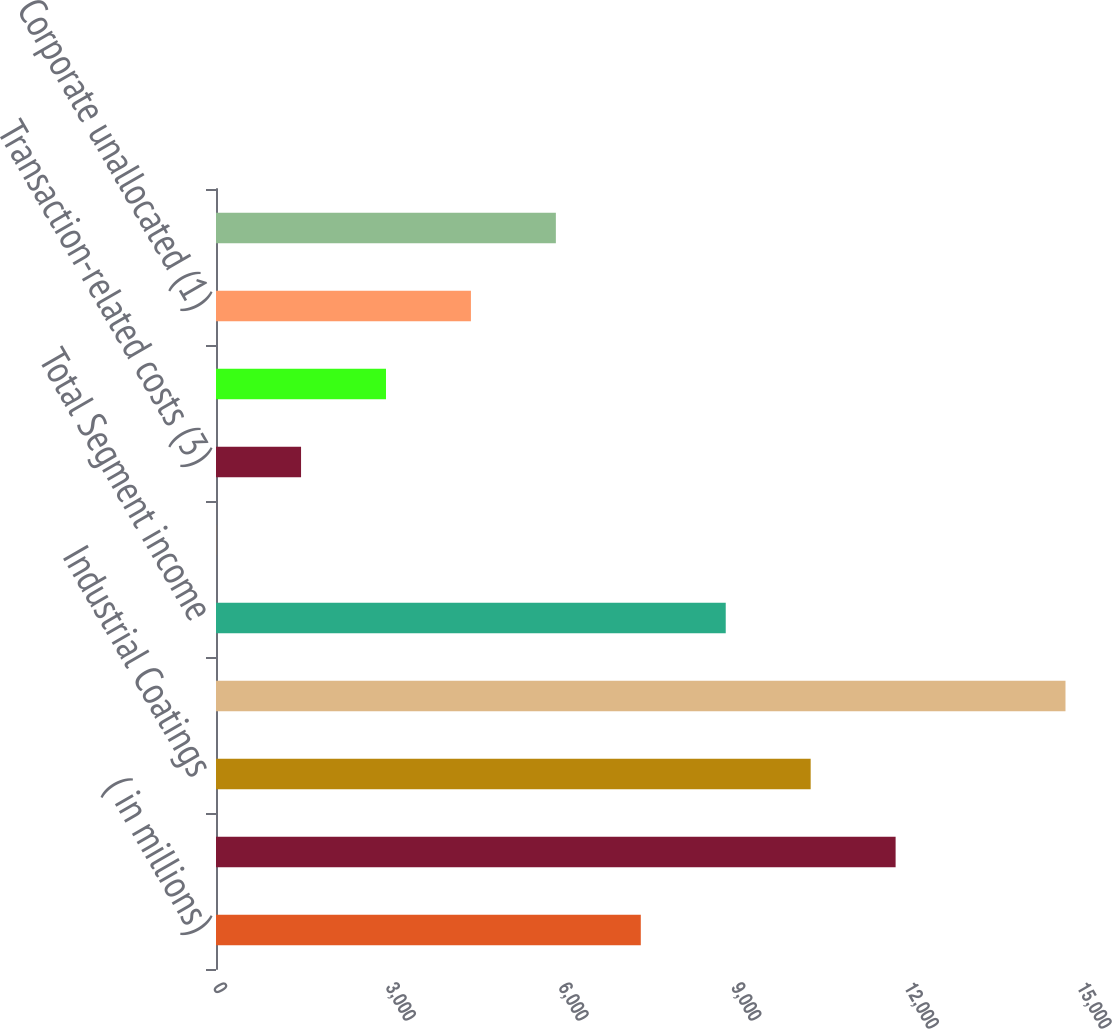<chart> <loc_0><loc_0><loc_500><loc_500><bar_chart><fcel>( in millions)<fcel>Performance Coatings<fcel>Industrial Coatings<fcel>Total Net sales<fcel>Total Segment income<fcel>Legacy items (2)<fcel>Transaction-related costs (3)<fcel>Interest expense net of<fcel>Corporate unallocated (1)<fcel>Total Income before income<nl><fcel>7375<fcel>11798.8<fcel>10324.2<fcel>14748<fcel>8849.6<fcel>2<fcel>1476.6<fcel>2951.2<fcel>4425.8<fcel>5900.4<nl></chart> 